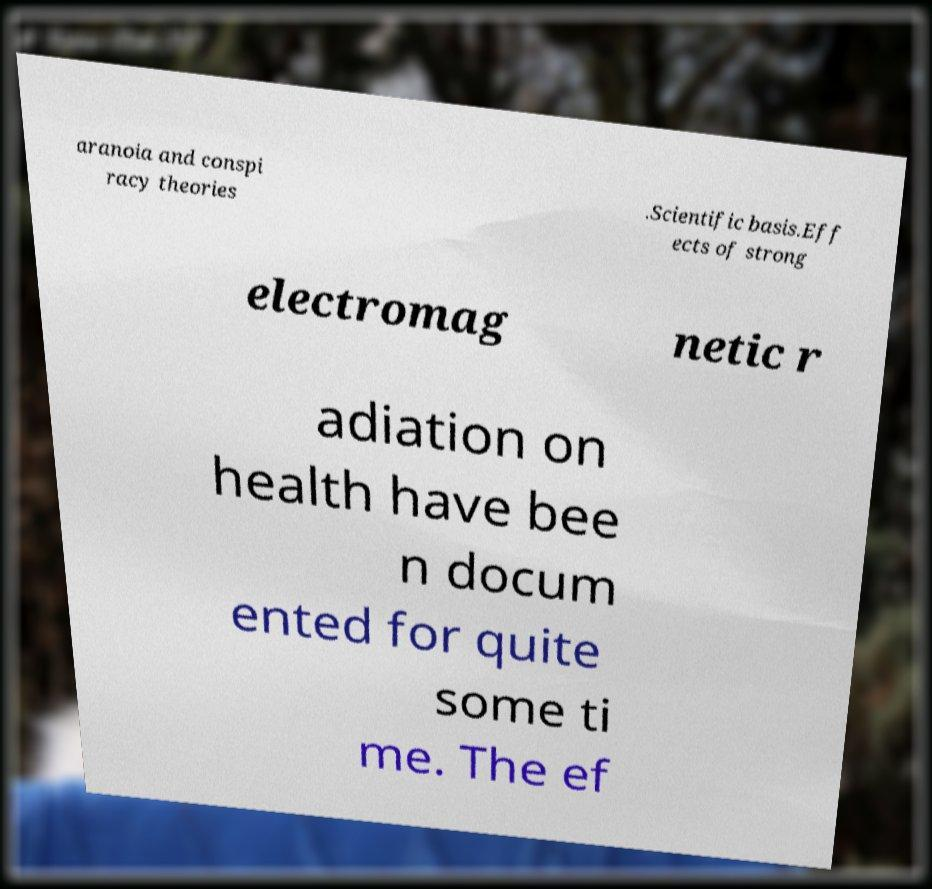What messages or text are displayed in this image? I need them in a readable, typed format. aranoia and conspi racy theories .Scientific basis.Eff ects of strong electromag netic r adiation on health have bee n docum ented for quite some ti me. The ef 